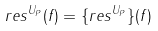Convert formula to latex. <formula><loc_0><loc_0><loc_500><loc_500>r e s ^ { U _ { P } } ( f ) = \{ r e s ^ { U _ { P } } \} ( f )</formula> 